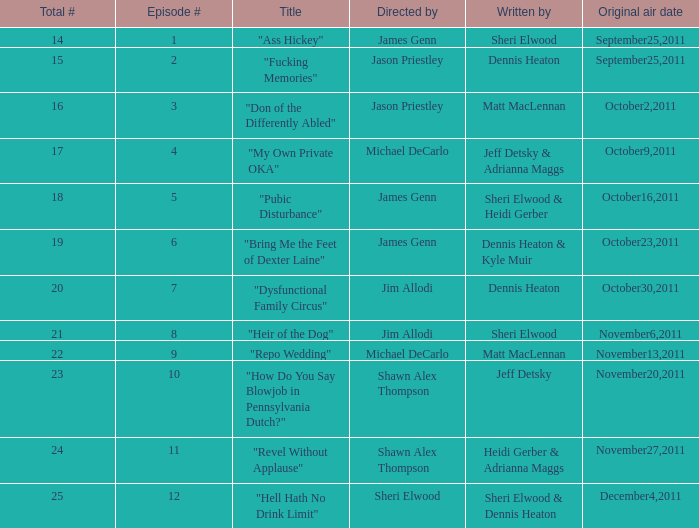How many different episode numbers are there for the episodes directed by Sheri Elwood? 1.0. Would you be able to parse every entry in this table? {'header': ['Total #', 'Episode #', 'Title', 'Directed by', 'Written by', 'Original air date'], 'rows': [['14', '1', '"Ass Hickey"', 'James Genn', 'Sheri Elwood', 'September25,2011'], ['15', '2', '"Fucking Memories"', 'Jason Priestley', 'Dennis Heaton', 'September25,2011'], ['16', '3', '"Don of the Differently Abled"', 'Jason Priestley', 'Matt MacLennan', 'October2,2011'], ['17', '4', '"My Own Private OKA"', 'Michael DeCarlo', 'Jeff Detsky & Adrianna Maggs', 'October9,2011'], ['18', '5', '"Pubic Disturbance"', 'James Genn', 'Sheri Elwood & Heidi Gerber', 'October16,2011'], ['19', '6', '"Bring Me the Feet of Dexter Laine"', 'James Genn', 'Dennis Heaton & Kyle Muir', 'October23,2011'], ['20', '7', '"Dysfunctional Family Circus"', 'Jim Allodi', 'Dennis Heaton', 'October30,2011'], ['21', '8', '"Heir of the Dog"', 'Jim Allodi', 'Sheri Elwood', 'November6,2011'], ['22', '9', '"Repo Wedding"', 'Michael DeCarlo', 'Matt MacLennan', 'November13,2011'], ['23', '10', '"How Do You Say Blowjob in Pennsylvania Dutch?"', 'Shawn Alex Thompson', 'Jeff Detsky', 'November20,2011'], ['24', '11', '"Revel Without Applause"', 'Shawn Alex Thompson', 'Heidi Gerber & Adrianna Maggs', 'November27,2011'], ['25', '12', '"Hell Hath No Drink Limit"', 'Sheri Elwood', 'Sheri Elwood & Dennis Heaton', 'December4,2011']]} 